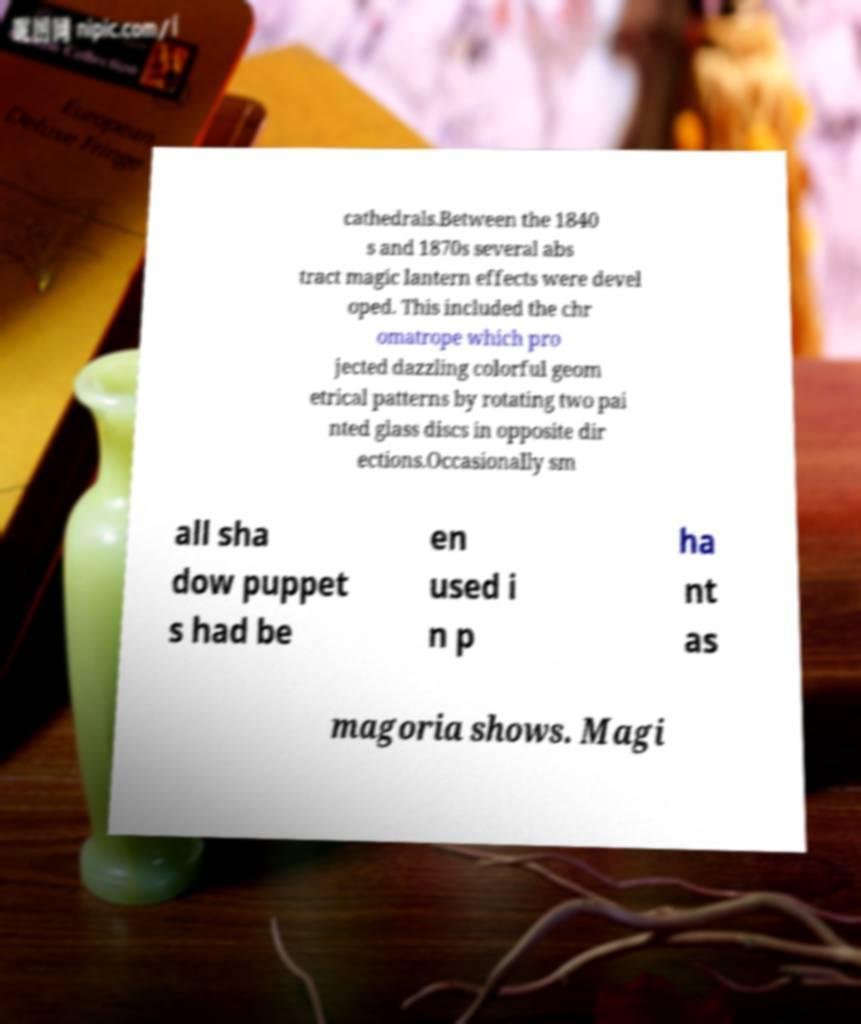For documentation purposes, I need the text within this image transcribed. Could you provide that? cathedrals.Between the 1840 s and 1870s several abs tract magic lantern effects were devel oped. This included the chr omatrope which pro jected dazzling colorful geom etrical patterns by rotating two pai nted glass discs in opposite dir ections.Occasionally sm all sha dow puppet s had be en used i n p ha nt as magoria shows. Magi 